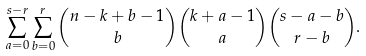<formula> <loc_0><loc_0><loc_500><loc_500>\sum _ { a = 0 } ^ { s - r } \sum _ { b = 0 } ^ { r } \binom { n - k + b - 1 } { b } \binom { k + a - 1 } { a } \binom { s - a - b } { r - b } .</formula> 